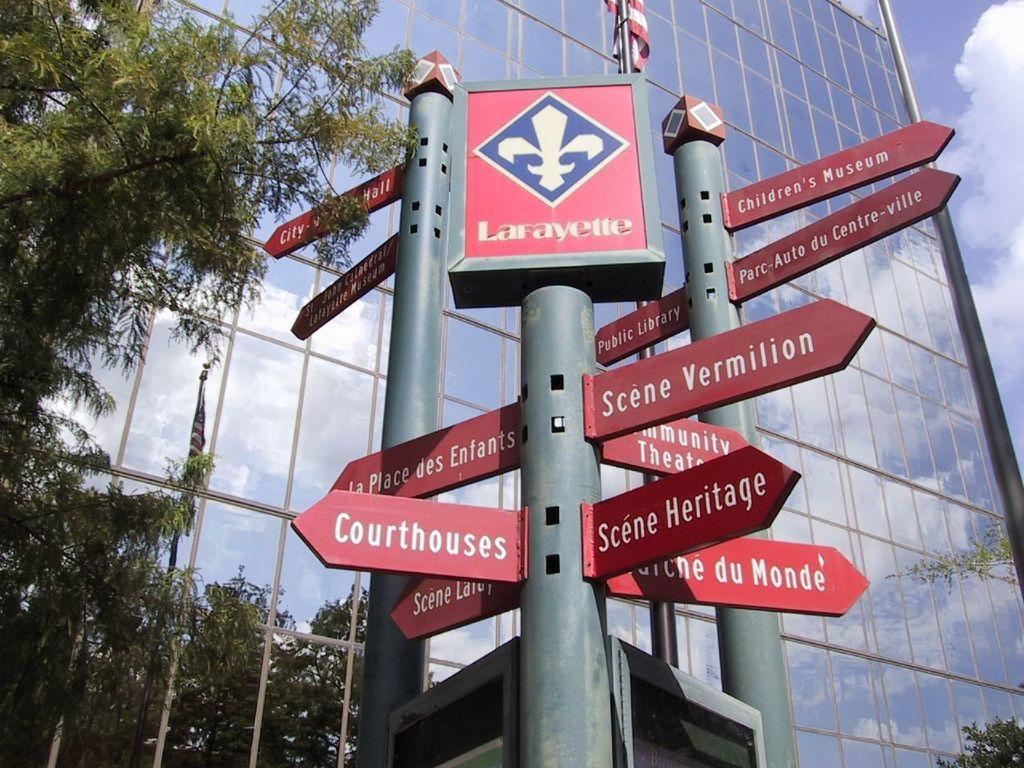What structures are present in the image? There are poles in the image. What is attached to the poles? There are sign boards on the poles. What type of vegetation can be seen in the image? There is a green tree in the image. What type of man-made structure is visible in the image? There is a building in the image. What is visible at the top of the image? The sky is visible at the top of the image. Can you tell me how many grapes are hanging from the tree in the image? There are no grapes present in the image; it features a green tree without any visible fruit. What type of carriage is parked in front of the building in the image? There is no carriage present in the image; it only features poles, sign boards, a green tree, a building, and the sky. 